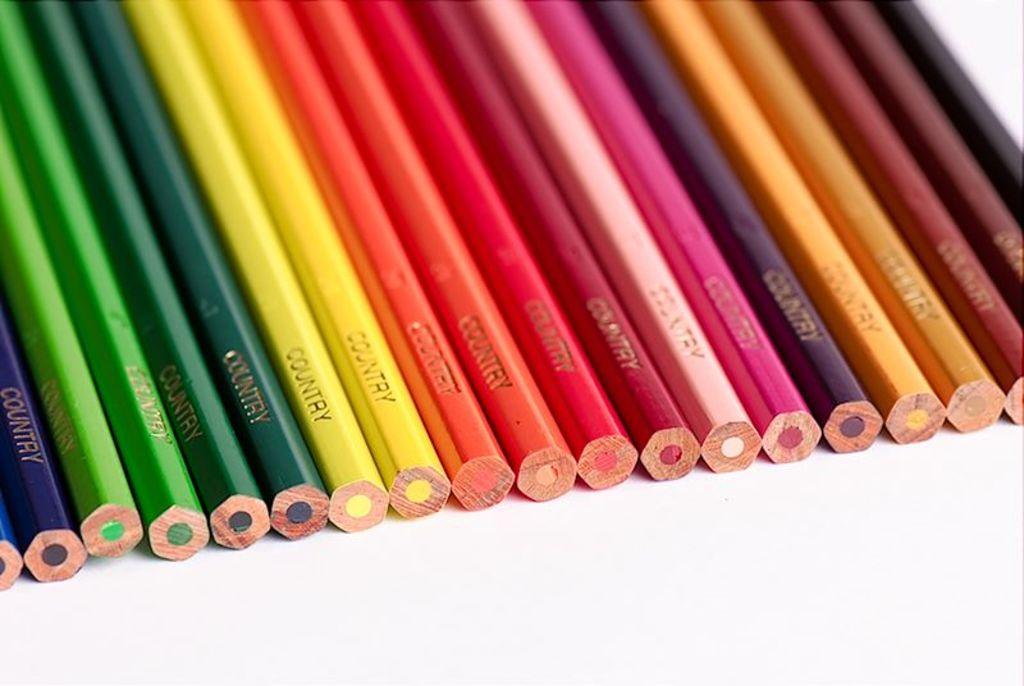What is the brand of these pencil crayons?
Make the answer very short. Country. 